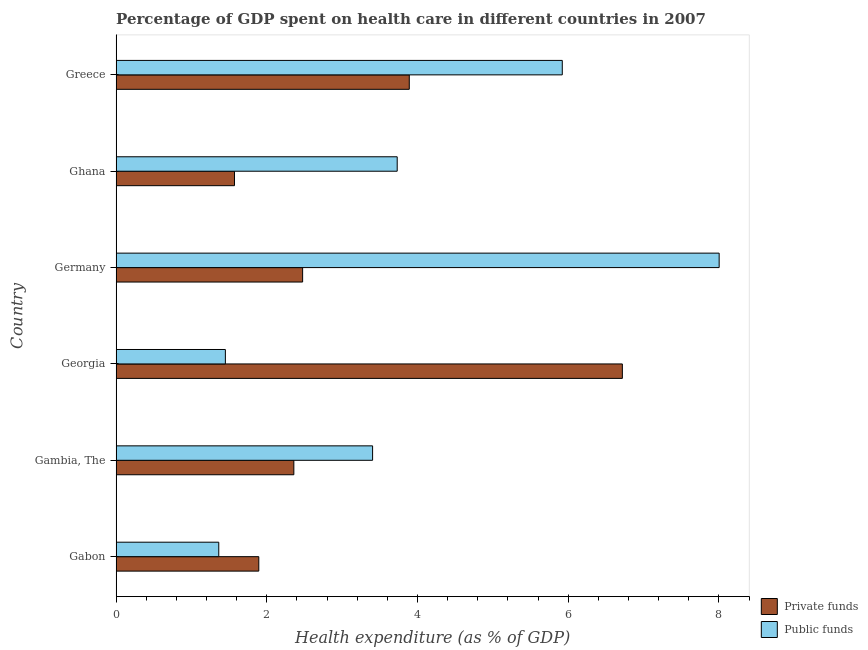How many groups of bars are there?
Give a very brief answer. 6. Are the number of bars on each tick of the Y-axis equal?
Your response must be concise. Yes. How many bars are there on the 6th tick from the bottom?
Give a very brief answer. 2. What is the label of the 6th group of bars from the top?
Provide a succinct answer. Gabon. What is the amount of public funds spent in healthcare in Gambia, The?
Provide a short and direct response. 3.4. Across all countries, what is the maximum amount of private funds spent in healthcare?
Your answer should be compact. 6.72. Across all countries, what is the minimum amount of public funds spent in healthcare?
Make the answer very short. 1.36. What is the total amount of public funds spent in healthcare in the graph?
Give a very brief answer. 23.87. What is the difference between the amount of public funds spent in healthcare in Georgia and that in Germany?
Make the answer very short. -6.55. What is the difference between the amount of private funds spent in healthcare in Ghana and the amount of public funds spent in healthcare in Gabon?
Provide a short and direct response. 0.21. What is the average amount of private funds spent in healthcare per country?
Your response must be concise. 3.15. What is the difference between the amount of private funds spent in healthcare and amount of public funds spent in healthcare in Gabon?
Your answer should be very brief. 0.53. In how many countries, is the amount of private funds spent in healthcare greater than 5.6 %?
Provide a succinct answer. 1. What is the ratio of the amount of private funds spent in healthcare in Gabon to that in Gambia, The?
Make the answer very short. 0.8. Is the amount of private funds spent in healthcare in Gambia, The less than that in Georgia?
Ensure brevity in your answer.  Yes. What is the difference between the highest and the second highest amount of public funds spent in healthcare?
Keep it short and to the point. 2.08. What is the difference between the highest and the lowest amount of public funds spent in healthcare?
Provide a succinct answer. 6.64. In how many countries, is the amount of public funds spent in healthcare greater than the average amount of public funds spent in healthcare taken over all countries?
Your answer should be very brief. 2. Is the sum of the amount of private funds spent in healthcare in Gambia, The and Greece greater than the maximum amount of public funds spent in healthcare across all countries?
Keep it short and to the point. No. What does the 1st bar from the top in Gabon represents?
Keep it short and to the point. Public funds. What does the 1st bar from the bottom in Ghana represents?
Make the answer very short. Private funds. How many countries are there in the graph?
Make the answer very short. 6. What is the title of the graph?
Keep it short and to the point. Percentage of GDP spent on health care in different countries in 2007. Does "Official aid received" appear as one of the legend labels in the graph?
Offer a very short reply. No. What is the label or title of the X-axis?
Offer a terse response. Health expenditure (as % of GDP). What is the label or title of the Y-axis?
Provide a short and direct response. Country. What is the Health expenditure (as % of GDP) of Private funds in Gabon?
Your answer should be very brief. 1.89. What is the Health expenditure (as % of GDP) of Public funds in Gabon?
Offer a terse response. 1.36. What is the Health expenditure (as % of GDP) of Private funds in Gambia, The?
Your answer should be very brief. 2.36. What is the Health expenditure (as % of GDP) of Public funds in Gambia, The?
Provide a succinct answer. 3.4. What is the Health expenditure (as % of GDP) of Private funds in Georgia?
Provide a succinct answer. 6.72. What is the Health expenditure (as % of GDP) in Public funds in Georgia?
Give a very brief answer. 1.45. What is the Health expenditure (as % of GDP) in Private funds in Germany?
Your answer should be compact. 2.47. What is the Health expenditure (as % of GDP) in Public funds in Germany?
Give a very brief answer. 8. What is the Health expenditure (as % of GDP) of Private funds in Ghana?
Your answer should be very brief. 1.57. What is the Health expenditure (as % of GDP) in Public funds in Ghana?
Give a very brief answer. 3.73. What is the Health expenditure (as % of GDP) in Private funds in Greece?
Your response must be concise. 3.89. What is the Health expenditure (as % of GDP) of Public funds in Greece?
Ensure brevity in your answer.  5.92. Across all countries, what is the maximum Health expenditure (as % of GDP) in Private funds?
Give a very brief answer. 6.72. Across all countries, what is the maximum Health expenditure (as % of GDP) in Public funds?
Offer a very short reply. 8. Across all countries, what is the minimum Health expenditure (as % of GDP) in Private funds?
Your answer should be compact. 1.57. Across all countries, what is the minimum Health expenditure (as % of GDP) in Public funds?
Offer a very short reply. 1.36. What is the total Health expenditure (as % of GDP) of Private funds in the graph?
Offer a terse response. 18.9. What is the total Health expenditure (as % of GDP) of Public funds in the graph?
Ensure brevity in your answer.  23.87. What is the difference between the Health expenditure (as % of GDP) of Private funds in Gabon and that in Gambia, The?
Your response must be concise. -0.47. What is the difference between the Health expenditure (as % of GDP) in Public funds in Gabon and that in Gambia, The?
Offer a very short reply. -2.04. What is the difference between the Health expenditure (as % of GDP) in Private funds in Gabon and that in Georgia?
Make the answer very short. -4.82. What is the difference between the Health expenditure (as % of GDP) in Public funds in Gabon and that in Georgia?
Your response must be concise. -0.09. What is the difference between the Health expenditure (as % of GDP) of Private funds in Gabon and that in Germany?
Offer a very short reply. -0.58. What is the difference between the Health expenditure (as % of GDP) of Public funds in Gabon and that in Germany?
Your answer should be compact. -6.64. What is the difference between the Health expenditure (as % of GDP) of Private funds in Gabon and that in Ghana?
Ensure brevity in your answer.  0.32. What is the difference between the Health expenditure (as % of GDP) of Public funds in Gabon and that in Ghana?
Provide a short and direct response. -2.37. What is the difference between the Health expenditure (as % of GDP) in Private funds in Gabon and that in Greece?
Provide a short and direct response. -2. What is the difference between the Health expenditure (as % of GDP) in Public funds in Gabon and that in Greece?
Make the answer very short. -4.56. What is the difference between the Health expenditure (as % of GDP) of Private funds in Gambia, The and that in Georgia?
Offer a very short reply. -4.36. What is the difference between the Health expenditure (as % of GDP) in Public funds in Gambia, The and that in Georgia?
Make the answer very short. 1.95. What is the difference between the Health expenditure (as % of GDP) in Private funds in Gambia, The and that in Germany?
Give a very brief answer. -0.12. What is the difference between the Health expenditure (as % of GDP) of Public funds in Gambia, The and that in Germany?
Offer a terse response. -4.6. What is the difference between the Health expenditure (as % of GDP) of Private funds in Gambia, The and that in Ghana?
Provide a short and direct response. 0.79. What is the difference between the Health expenditure (as % of GDP) of Public funds in Gambia, The and that in Ghana?
Offer a terse response. -0.33. What is the difference between the Health expenditure (as % of GDP) of Private funds in Gambia, The and that in Greece?
Offer a terse response. -1.53. What is the difference between the Health expenditure (as % of GDP) of Public funds in Gambia, The and that in Greece?
Give a very brief answer. -2.52. What is the difference between the Health expenditure (as % of GDP) in Private funds in Georgia and that in Germany?
Your answer should be very brief. 4.24. What is the difference between the Health expenditure (as % of GDP) of Public funds in Georgia and that in Germany?
Offer a terse response. -6.55. What is the difference between the Health expenditure (as % of GDP) of Private funds in Georgia and that in Ghana?
Offer a terse response. 5.15. What is the difference between the Health expenditure (as % of GDP) of Public funds in Georgia and that in Ghana?
Offer a very short reply. -2.28. What is the difference between the Health expenditure (as % of GDP) in Private funds in Georgia and that in Greece?
Provide a succinct answer. 2.83. What is the difference between the Health expenditure (as % of GDP) in Public funds in Georgia and that in Greece?
Your answer should be compact. -4.47. What is the difference between the Health expenditure (as % of GDP) of Private funds in Germany and that in Ghana?
Provide a short and direct response. 0.9. What is the difference between the Health expenditure (as % of GDP) of Public funds in Germany and that in Ghana?
Offer a very short reply. 4.27. What is the difference between the Health expenditure (as % of GDP) in Private funds in Germany and that in Greece?
Provide a short and direct response. -1.42. What is the difference between the Health expenditure (as % of GDP) in Public funds in Germany and that in Greece?
Your response must be concise. 2.08. What is the difference between the Health expenditure (as % of GDP) of Private funds in Ghana and that in Greece?
Keep it short and to the point. -2.32. What is the difference between the Health expenditure (as % of GDP) of Public funds in Ghana and that in Greece?
Keep it short and to the point. -2.19. What is the difference between the Health expenditure (as % of GDP) in Private funds in Gabon and the Health expenditure (as % of GDP) in Public funds in Gambia, The?
Offer a very short reply. -1.51. What is the difference between the Health expenditure (as % of GDP) of Private funds in Gabon and the Health expenditure (as % of GDP) of Public funds in Georgia?
Provide a short and direct response. 0.44. What is the difference between the Health expenditure (as % of GDP) of Private funds in Gabon and the Health expenditure (as % of GDP) of Public funds in Germany?
Your answer should be very brief. -6.11. What is the difference between the Health expenditure (as % of GDP) of Private funds in Gabon and the Health expenditure (as % of GDP) of Public funds in Ghana?
Offer a very short reply. -1.84. What is the difference between the Health expenditure (as % of GDP) in Private funds in Gabon and the Health expenditure (as % of GDP) in Public funds in Greece?
Provide a succinct answer. -4.03. What is the difference between the Health expenditure (as % of GDP) in Private funds in Gambia, The and the Health expenditure (as % of GDP) in Public funds in Georgia?
Keep it short and to the point. 0.91. What is the difference between the Health expenditure (as % of GDP) of Private funds in Gambia, The and the Health expenditure (as % of GDP) of Public funds in Germany?
Your response must be concise. -5.64. What is the difference between the Health expenditure (as % of GDP) of Private funds in Gambia, The and the Health expenditure (as % of GDP) of Public funds in Ghana?
Provide a short and direct response. -1.37. What is the difference between the Health expenditure (as % of GDP) in Private funds in Gambia, The and the Health expenditure (as % of GDP) in Public funds in Greece?
Make the answer very short. -3.56. What is the difference between the Health expenditure (as % of GDP) in Private funds in Georgia and the Health expenditure (as % of GDP) in Public funds in Germany?
Keep it short and to the point. -1.28. What is the difference between the Health expenditure (as % of GDP) of Private funds in Georgia and the Health expenditure (as % of GDP) of Public funds in Ghana?
Offer a very short reply. 2.99. What is the difference between the Health expenditure (as % of GDP) in Private funds in Georgia and the Health expenditure (as % of GDP) in Public funds in Greece?
Your response must be concise. 0.8. What is the difference between the Health expenditure (as % of GDP) in Private funds in Germany and the Health expenditure (as % of GDP) in Public funds in Ghana?
Provide a short and direct response. -1.26. What is the difference between the Health expenditure (as % of GDP) of Private funds in Germany and the Health expenditure (as % of GDP) of Public funds in Greece?
Your answer should be compact. -3.45. What is the difference between the Health expenditure (as % of GDP) in Private funds in Ghana and the Health expenditure (as % of GDP) in Public funds in Greece?
Ensure brevity in your answer.  -4.35. What is the average Health expenditure (as % of GDP) of Private funds per country?
Your response must be concise. 3.15. What is the average Health expenditure (as % of GDP) of Public funds per country?
Your response must be concise. 3.98. What is the difference between the Health expenditure (as % of GDP) in Private funds and Health expenditure (as % of GDP) in Public funds in Gabon?
Offer a very short reply. 0.53. What is the difference between the Health expenditure (as % of GDP) in Private funds and Health expenditure (as % of GDP) in Public funds in Gambia, The?
Give a very brief answer. -1.04. What is the difference between the Health expenditure (as % of GDP) in Private funds and Health expenditure (as % of GDP) in Public funds in Georgia?
Offer a terse response. 5.27. What is the difference between the Health expenditure (as % of GDP) in Private funds and Health expenditure (as % of GDP) in Public funds in Germany?
Your response must be concise. -5.53. What is the difference between the Health expenditure (as % of GDP) of Private funds and Health expenditure (as % of GDP) of Public funds in Ghana?
Offer a terse response. -2.16. What is the difference between the Health expenditure (as % of GDP) of Private funds and Health expenditure (as % of GDP) of Public funds in Greece?
Keep it short and to the point. -2.03. What is the ratio of the Health expenditure (as % of GDP) in Private funds in Gabon to that in Gambia, The?
Keep it short and to the point. 0.8. What is the ratio of the Health expenditure (as % of GDP) of Public funds in Gabon to that in Gambia, The?
Your answer should be compact. 0.4. What is the ratio of the Health expenditure (as % of GDP) of Private funds in Gabon to that in Georgia?
Provide a succinct answer. 0.28. What is the ratio of the Health expenditure (as % of GDP) of Public funds in Gabon to that in Georgia?
Give a very brief answer. 0.94. What is the ratio of the Health expenditure (as % of GDP) of Private funds in Gabon to that in Germany?
Offer a very short reply. 0.77. What is the ratio of the Health expenditure (as % of GDP) in Public funds in Gabon to that in Germany?
Make the answer very short. 0.17. What is the ratio of the Health expenditure (as % of GDP) of Private funds in Gabon to that in Ghana?
Make the answer very short. 1.21. What is the ratio of the Health expenditure (as % of GDP) in Public funds in Gabon to that in Ghana?
Offer a very short reply. 0.37. What is the ratio of the Health expenditure (as % of GDP) in Private funds in Gabon to that in Greece?
Offer a terse response. 0.49. What is the ratio of the Health expenditure (as % of GDP) in Public funds in Gabon to that in Greece?
Make the answer very short. 0.23. What is the ratio of the Health expenditure (as % of GDP) in Private funds in Gambia, The to that in Georgia?
Your answer should be compact. 0.35. What is the ratio of the Health expenditure (as % of GDP) of Public funds in Gambia, The to that in Georgia?
Give a very brief answer. 2.35. What is the ratio of the Health expenditure (as % of GDP) of Private funds in Gambia, The to that in Germany?
Provide a succinct answer. 0.95. What is the ratio of the Health expenditure (as % of GDP) in Public funds in Gambia, The to that in Germany?
Provide a succinct answer. 0.43. What is the ratio of the Health expenditure (as % of GDP) of Private funds in Gambia, The to that in Ghana?
Make the answer very short. 1.5. What is the ratio of the Health expenditure (as % of GDP) of Public funds in Gambia, The to that in Ghana?
Give a very brief answer. 0.91. What is the ratio of the Health expenditure (as % of GDP) in Private funds in Gambia, The to that in Greece?
Keep it short and to the point. 0.61. What is the ratio of the Health expenditure (as % of GDP) in Public funds in Gambia, The to that in Greece?
Your answer should be compact. 0.57. What is the ratio of the Health expenditure (as % of GDP) in Private funds in Georgia to that in Germany?
Ensure brevity in your answer.  2.71. What is the ratio of the Health expenditure (as % of GDP) of Public funds in Georgia to that in Germany?
Provide a succinct answer. 0.18. What is the ratio of the Health expenditure (as % of GDP) of Private funds in Georgia to that in Ghana?
Offer a terse response. 4.28. What is the ratio of the Health expenditure (as % of GDP) in Public funds in Georgia to that in Ghana?
Keep it short and to the point. 0.39. What is the ratio of the Health expenditure (as % of GDP) in Private funds in Georgia to that in Greece?
Your response must be concise. 1.73. What is the ratio of the Health expenditure (as % of GDP) of Public funds in Georgia to that in Greece?
Keep it short and to the point. 0.24. What is the ratio of the Health expenditure (as % of GDP) of Private funds in Germany to that in Ghana?
Make the answer very short. 1.58. What is the ratio of the Health expenditure (as % of GDP) in Public funds in Germany to that in Ghana?
Give a very brief answer. 2.15. What is the ratio of the Health expenditure (as % of GDP) of Private funds in Germany to that in Greece?
Give a very brief answer. 0.64. What is the ratio of the Health expenditure (as % of GDP) in Public funds in Germany to that in Greece?
Offer a terse response. 1.35. What is the ratio of the Health expenditure (as % of GDP) of Private funds in Ghana to that in Greece?
Give a very brief answer. 0.4. What is the ratio of the Health expenditure (as % of GDP) of Public funds in Ghana to that in Greece?
Offer a very short reply. 0.63. What is the difference between the highest and the second highest Health expenditure (as % of GDP) in Private funds?
Offer a terse response. 2.83. What is the difference between the highest and the second highest Health expenditure (as % of GDP) of Public funds?
Your answer should be compact. 2.08. What is the difference between the highest and the lowest Health expenditure (as % of GDP) of Private funds?
Your response must be concise. 5.15. What is the difference between the highest and the lowest Health expenditure (as % of GDP) of Public funds?
Your answer should be very brief. 6.64. 